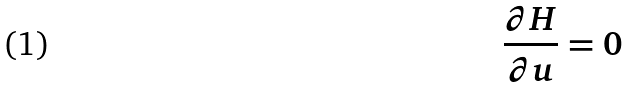Convert formula to latex. <formula><loc_0><loc_0><loc_500><loc_500>\frac { \partial H } { \partial u } = 0</formula> 